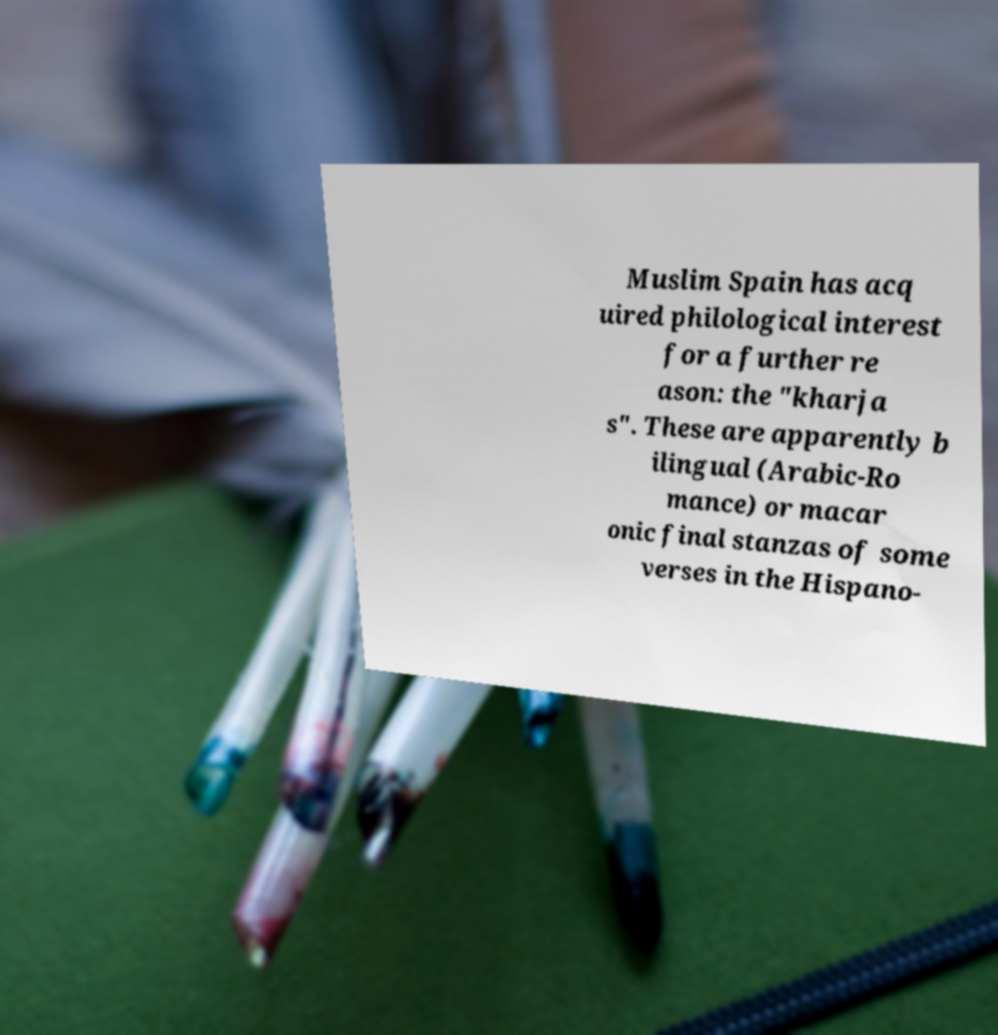Please identify and transcribe the text found in this image. Muslim Spain has acq uired philological interest for a further re ason: the "kharja s". These are apparently b ilingual (Arabic-Ro mance) or macar onic final stanzas of some verses in the Hispano- 